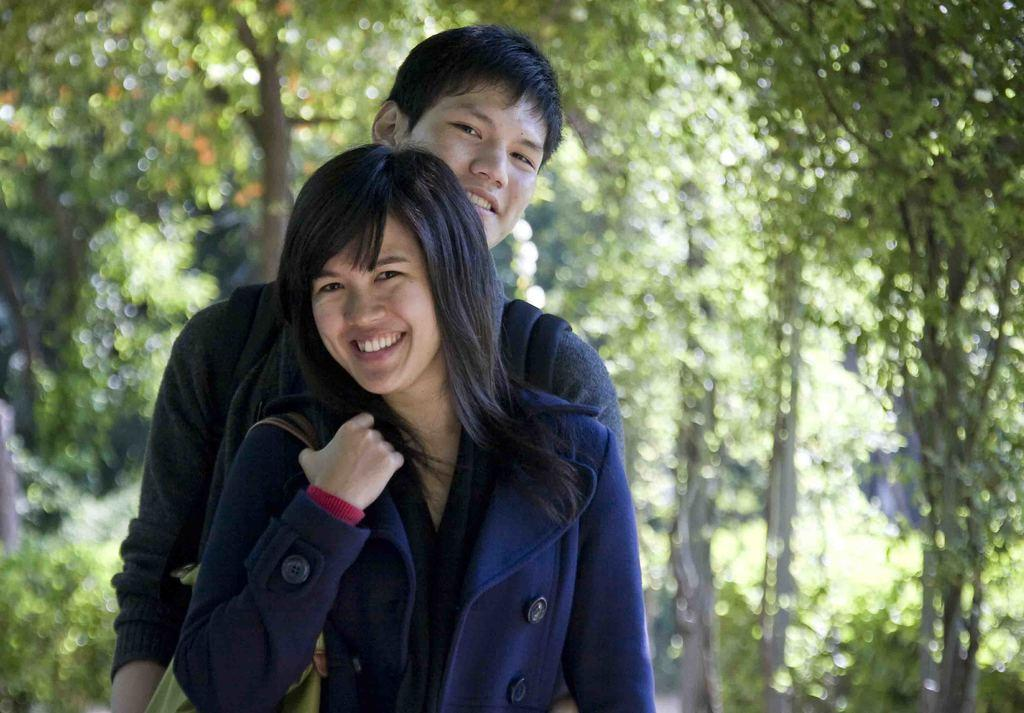What are the two main subjects in the image? There is a boy and a girl in the image. Where are the boy and girl located in the image? The boy and girl are standing in the foreground area. What can be seen in the background area of the image? There is greenery visible in the background area of the image. Can you see any mountains in the image? There are no mountains visible in the image. What type of attraction is present in the image? There is no specific attraction mentioned or visible in the image. 